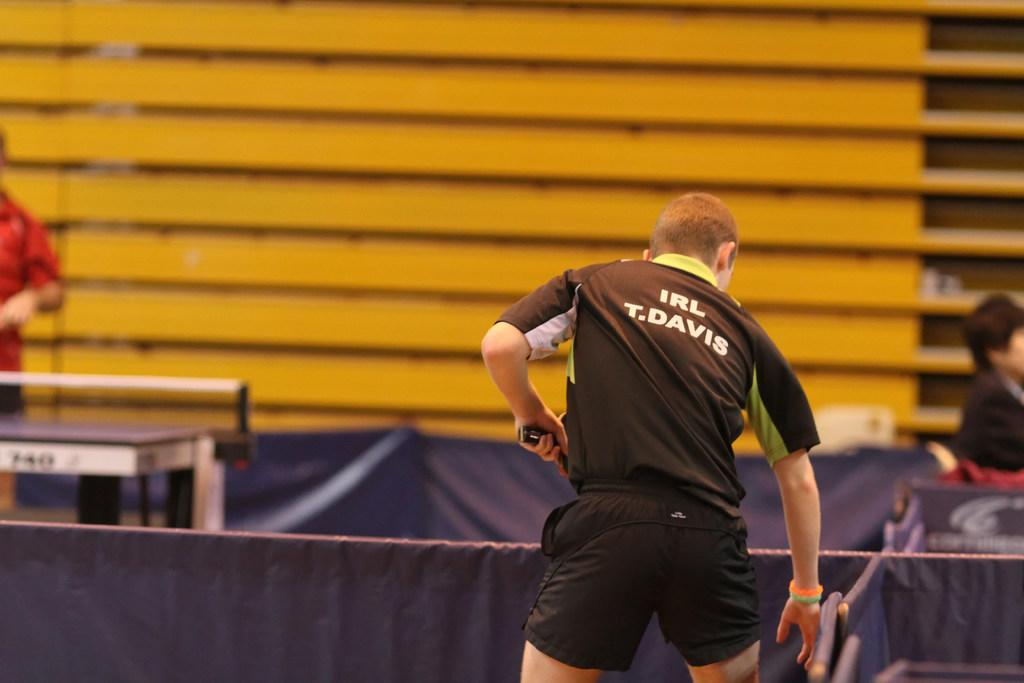What is the man holding in the image? The information provided does not specify what the man is holding. Can you describe the person sitting on the right side of the image? There is a person sitting on the right side of the image, but no further details are given. What is the position of the person standing on the left side of the image? The person standing on the left side of the image is standing, as mentioned in the fact. What can be seen in the background of the image? There is a wall in the background of the image. What type of tin is the person sitting on in the image? There is no tin present in the image; the person is sitting on an unspecified surface. 